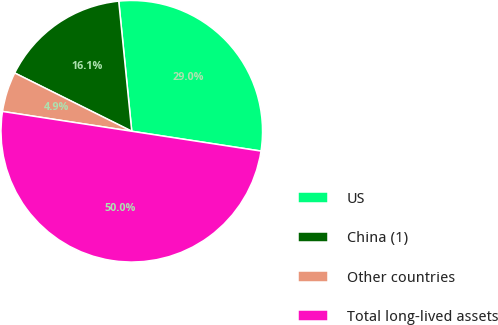<chart> <loc_0><loc_0><loc_500><loc_500><pie_chart><fcel>US<fcel>China (1)<fcel>Other countries<fcel>Total long-lived assets<nl><fcel>29.01%<fcel>16.06%<fcel>4.93%<fcel>50.0%<nl></chart> 